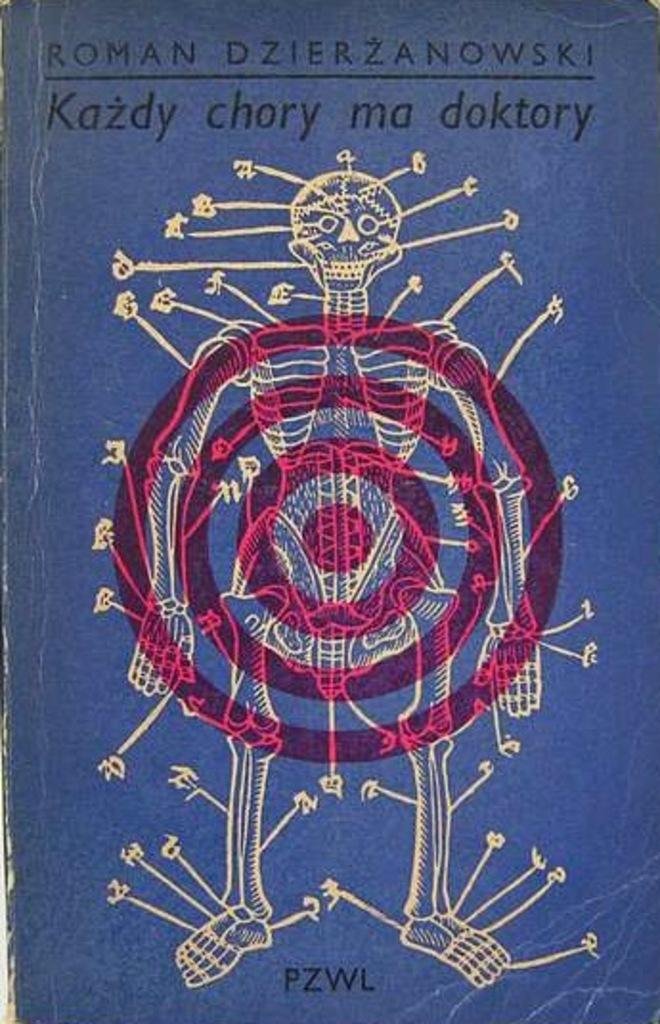What is the main subject of the image? There is a skeleton in the image. Are there any words or phrases written on the image? Yes, there are texts written on the image. What is the color of the image? The image is blue in color. Can you tell me how many women are walking in the store in the image? There is no store or woman present in the image; it features a skeleton and texts on a blue background. 